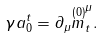Convert formula to latex. <formula><loc_0><loc_0><loc_500><loc_500>\gamma a _ { 0 } ^ { t } = \partial _ { \mu } \overset { ( 0 ) } { m } _ { t } ^ { \mu } .</formula> 